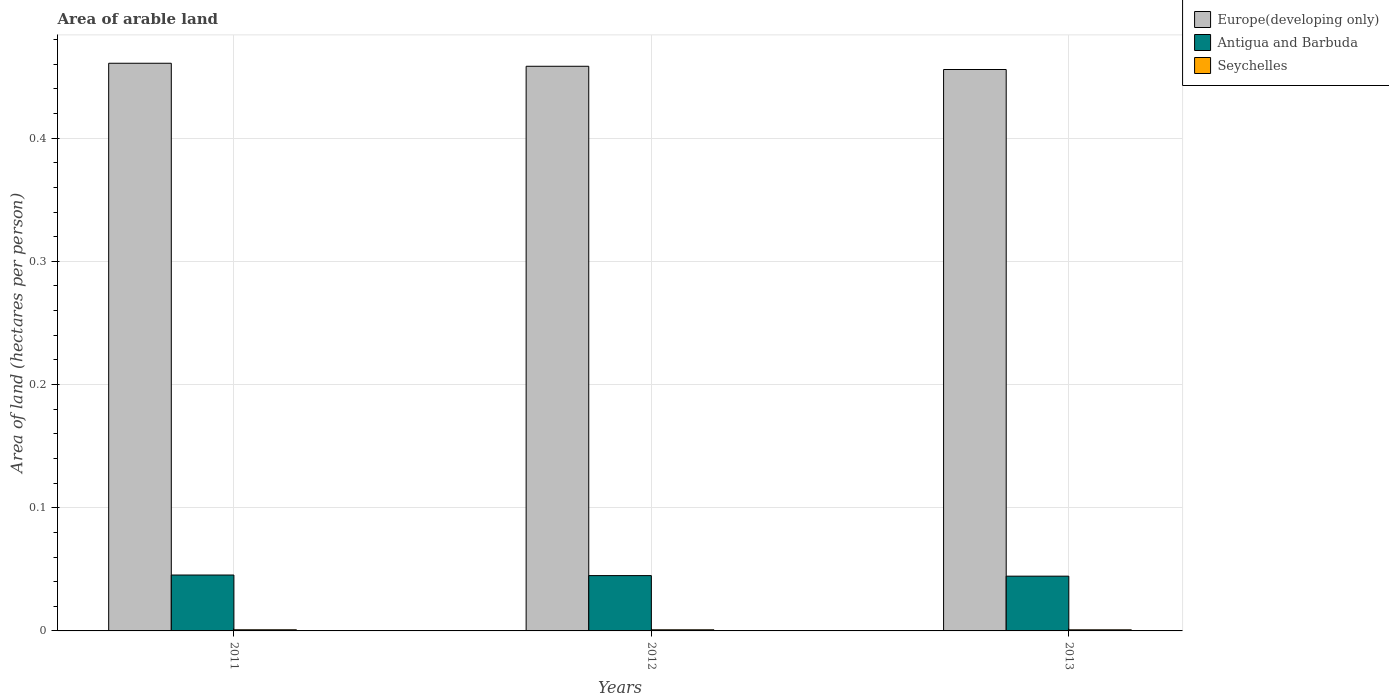How many groups of bars are there?
Offer a very short reply. 3. Are the number of bars on each tick of the X-axis equal?
Ensure brevity in your answer.  Yes. What is the label of the 2nd group of bars from the left?
Ensure brevity in your answer.  2012. What is the total arable land in Antigua and Barbuda in 2012?
Make the answer very short. 0.04. Across all years, what is the maximum total arable land in Antigua and Barbuda?
Give a very brief answer. 0.05. Across all years, what is the minimum total arable land in Europe(developing only)?
Your answer should be very brief. 0.46. In which year was the total arable land in Europe(developing only) minimum?
Keep it short and to the point. 2013. What is the total total arable land in Antigua and Barbuda in the graph?
Your answer should be compact. 0.13. What is the difference between the total arable land in Europe(developing only) in 2012 and that in 2013?
Offer a very short reply. 0. What is the difference between the total arable land in Seychelles in 2011 and the total arable land in Antigua and Barbuda in 2012?
Provide a succinct answer. -0.04. What is the average total arable land in Antigua and Barbuda per year?
Your answer should be compact. 0.04. In the year 2013, what is the difference between the total arable land in Seychelles and total arable land in Antigua and Barbuda?
Provide a succinct answer. -0.04. In how many years, is the total arable land in Europe(developing only) greater than 0.14 hectares per person?
Ensure brevity in your answer.  3. What is the ratio of the total arable land in Europe(developing only) in 2012 to that in 2013?
Offer a terse response. 1.01. Is the total arable land in Seychelles in 2012 less than that in 2013?
Provide a short and direct response. No. Is the difference between the total arable land in Seychelles in 2011 and 2012 greater than the difference between the total arable land in Antigua and Barbuda in 2011 and 2012?
Your response must be concise. No. What is the difference between the highest and the second highest total arable land in Antigua and Barbuda?
Give a very brief answer. 0. What is the difference between the highest and the lowest total arable land in Antigua and Barbuda?
Your response must be concise. 0. Is the sum of the total arable land in Antigua and Barbuda in 2011 and 2013 greater than the maximum total arable land in Europe(developing only) across all years?
Give a very brief answer. No. What does the 2nd bar from the left in 2013 represents?
Ensure brevity in your answer.  Antigua and Barbuda. What does the 2nd bar from the right in 2013 represents?
Your response must be concise. Antigua and Barbuda. Are all the bars in the graph horizontal?
Offer a terse response. No. How many years are there in the graph?
Make the answer very short. 3. Are the values on the major ticks of Y-axis written in scientific E-notation?
Offer a terse response. No. Does the graph contain any zero values?
Offer a very short reply. No. How many legend labels are there?
Ensure brevity in your answer.  3. What is the title of the graph?
Make the answer very short. Area of arable land. Does "United Arab Emirates" appear as one of the legend labels in the graph?
Provide a succinct answer. No. What is the label or title of the X-axis?
Give a very brief answer. Years. What is the label or title of the Y-axis?
Ensure brevity in your answer.  Area of land (hectares per person). What is the Area of land (hectares per person) of Europe(developing only) in 2011?
Your answer should be compact. 0.46. What is the Area of land (hectares per person) of Antigua and Barbuda in 2011?
Give a very brief answer. 0.05. What is the Area of land (hectares per person) of Seychelles in 2011?
Offer a very short reply. 0. What is the Area of land (hectares per person) in Europe(developing only) in 2012?
Provide a short and direct response. 0.46. What is the Area of land (hectares per person) in Antigua and Barbuda in 2012?
Make the answer very short. 0.04. What is the Area of land (hectares per person) in Seychelles in 2012?
Make the answer very short. 0. What is the Area of land (hectares per person) in Europe(developing only) in 2013?
Keep it short and to the point. 0.46. What is the Area of land (hectares per person) of Antigua and Barbuda in 2013?
Provide a short and direct response. 0.04. What is the Area of land (hectares per person) in Seychelles in 2013?
Ensure brevity in your answer.  0. Across all years, what is the maximum Area of land (hectares per person) of Europe(developing only)?
Provide a short and direct response. 0.46. Across all years, what is the maximum Area of land (hectares per person) of Antigua and Barbuda?
Offer a terse response. 0.05. Across all years, what is the maximum Area of land (hectares per person) in Seychelles?
Your answer should be very brief. 0. Across all years, what is the minimum Area of land (hectares per person) in Europe(developing only)?
Your answer should be very brief. 0.46. Across all years, what is the minimum Area of land (hectares per person) in Antigua and Barbuda?
Give a very brief answer. 0.04. Across all years, what is the minimum Area of land (hectares per person) in Seychelles?
Give a very brief answer. 0. What is the total Area of land (hectares per person) in Europe(developing only) in the graph?
Keep it short and to the point. 1.37. What is the total Area of land (hectares per person) in Antigua and Barbuda in the graph?
Your answer should be very brief. 0.13. What is the total Area of land (hectares per person) of Seychelles in the graph?
Your answer should be very brief. 0. What is the difference between the Area of land (hectares per person) of Europe(developing only) in 2011 and that in 2012?
Provide a short and direct response. 0. What is the difference between the Area of land (hectares per person) in Antigua and Barbuda in 2011 and that in 2012?
Keep it short and to the point. 0. What is the difference between the Area of land (hectares per person) in Seychelles in 2011 and that in 2012?
Provide a short and direct response. 0. What is the difference between the Area of land (hectares per person) in Europe(developing only) in 2011 and that in 2013?
Offer a terse response. 0.01. What is the difference between the Area of land (hectares per person) of Antigua and Barbuda in 2011 and that in 2013?
Give a very brief answer. 0. What is the difference between the Area of land (hectares per person) of Europe(developing only) in 2012 and that in 2013?
Offer a very short reply. 0. What is the difference between the Area of land (hectares per person) in Antigua and Barbuda in 2012 and that in 2013?
Offer a very short reply. 0. What is the difference between the Area of land (hectares per person) of Seychelles in 2012 and that in 2013?
Keep it short and to the point. 0. What is the difference between the Area of land (hectares per person) of Europe(developing only) in 2011 and the Area of land (hectares per person) of Antigua and Barbuda in 2012?
Make the answer very short. 0.42. What is the difference between the Area of land (hectares per person) in Europe(developing only) in 2011 and the Area of land (hectares per person) in Seychelles in 2012?
Ensure brevity in your answer.  0.46. What is the difference between the Area of land (hectares per person) of Antigua and Barbuda in 2011 and the Area of land (hectares per person) of Seychelles in 2012?
Ensure brevity in your answer.  0.04. What is the difference between the Area of land (hectares per person) of Europe(developing only) in 2011 and the Area of land (hectares per person) of Antigua and Barbuda in 2013?
Your answer should be very brief. 0.42. What is the difference between the Area of land (hectares per person) of Europe(developing only) in 2011 and the Area of land (hectares per person) of Seychelles in 2013?
Offer a very short reply. 0.46. What is the difference between the Area of land (hectares per person) in Antigua and Barbuda in 2011 and the Area of land (hectares per person) in Seychelles in 2013?
Your answer should be compact. 0.04. What is the difference between the Area of land (hectares per person) in Europe(developing only) in 2012 and the Area of land (hectares per person) in Antigua and Barbuda in 2013?
Offer a terse response. 0.41. What is the difference between the Area of land (hectares per person) of Europe(developing only) in 2012 and the Area of land (hectares per person) of Seychelles in 2013?
Keep it short and to the point. 0.46. What is the difference between the Area of land (hectares per person) of Antigua and Barbuda in 2012 and the Area of land (hectares per person) of Seychelles in 2013?
Offer a very short reply. 0.04. What is the average Area of land (hectares per person) of Europe(developing only) per year?
Offer a very short reply. 0.46. What is the average Area of land (hectares per person) of Antigua and Barbuda per year?
Provide a short and direct response. 0.04. What is the average Area of land (hectares per person) of Seychelles per year?
Keep it short and to the point. 0. In the year 2011, what is the difference between the Area of land (hectares per person) of Europe(developing only) and Area of land (hectares per person) of Antigua and Barbuda?
Make the answer very short. 0.42. In the year 2011, what is the difference between the Area of land (hectares per person) of Europe(developing only) and Area of land (hectares per person) of Seychelles?
Give a very brief answer. 0.46. In the year 2011, what is the difference between the Area of land (hectares per person) in Antigua and Barbuda and Area of land (hectares per person) in Seychelles?
Provide a short and direct response. 0.04. In the year 2012, what is the difference between the Area of land (hectares per person) of Europe(developing only) and Area of land (hectares per person) of Antigua and Barbuda?
Provide a short and direct response. 0.41. In the year 2012, what is the difference between the Area of land (hectares per person) in Europe(developing only) and Area of land (hectares per person) in Seychelles?
Your response must be concise. 0.46. In the year 2012, what is the difference between the Area of land (hectares per person) of Antigua and Barbuda and Area of land (hectares per person) of Seychelles?
Make the answer very short. 0.04. In the year 2013, what is the difference between the Area of land (hectares per person) in Europe(developing only) and Area of land (hectares per person) in Antigua and Barbuda?
Give a very brief answer. 0.41. In the year 2013, what is the difference between the Area of land (hectares per person) of Europe(developing only) and Area of land (hectares per person) of Seychelles?
Keep it short and to the point. 0.45. In the year 2013, what is the difference between the Area of land (hectares per person) in Antigua and Barbuda and Area of land (hectares per person) in Seychelles?
Ensure brevity in your answer.  0.04. What is the ratio of the Area of land (hectares per person) in Antigua and Barbuda in 2011 to that in 2012?
Give a very brief answer. 1.01. What is the ratio of the Area of land (hectares per person) in Seychelles in 2011 to that in 2012?
Your answer should be compact. 1.01. What is the ratio of the Area of land (hectares per person) in Europe(developing only) in 2011 to that in 2013?
Give a very brief answer. 1.01. What is the ratio of the Area of land (hectares per person) of Antigua and Barbuda in 2011 to that in 2013?
Provide a succinct answer. 1.02. What is the ratio of the Area of land (hectares per person) in Seychelles in 2011 to that in 2013?
Make the answer very short. 1.03. What is the ratio of the Area of land (hectares per person) in Antigua and Barbuda in 2012 to that in 2013?
Your response must be concise. 1.01. What is the ratio of the Area of land (hectares per person) in Seychelles in 2012 to that in 2013?
Provide a short and direct response. 1.02. What is the difference between the highest and the second highest Area of land (hectares per person) in Europe(developing only)?
Your response must be concise. 0. What is the difference between the highest and the lowest Area of land (hectares per person) in Europe(developing only)?
Provide a succinct answer. 0.01. What is the difference between the highest and the lowest Area of land (hectares per person) in Antigua and Barbuda?
Provide a succinct answer. 0. What is the difference between the highest and the lowest Area of land (hectares per person) of Seychelles?
Offer a very short reply. 0. 